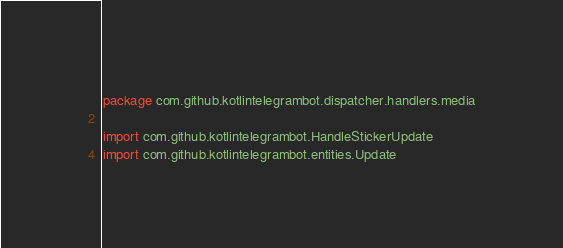Convert code to text. <code><loc_0><loc_0><loc_500><loc_500><_Kotlin_>package com.github.kotlintelegrambot.dispatcher.handlers.media

import com.github.kotlintelegrambot.HandleStickerUpdate
import com.github.kotlintelegrambot.entities.Update</code> 